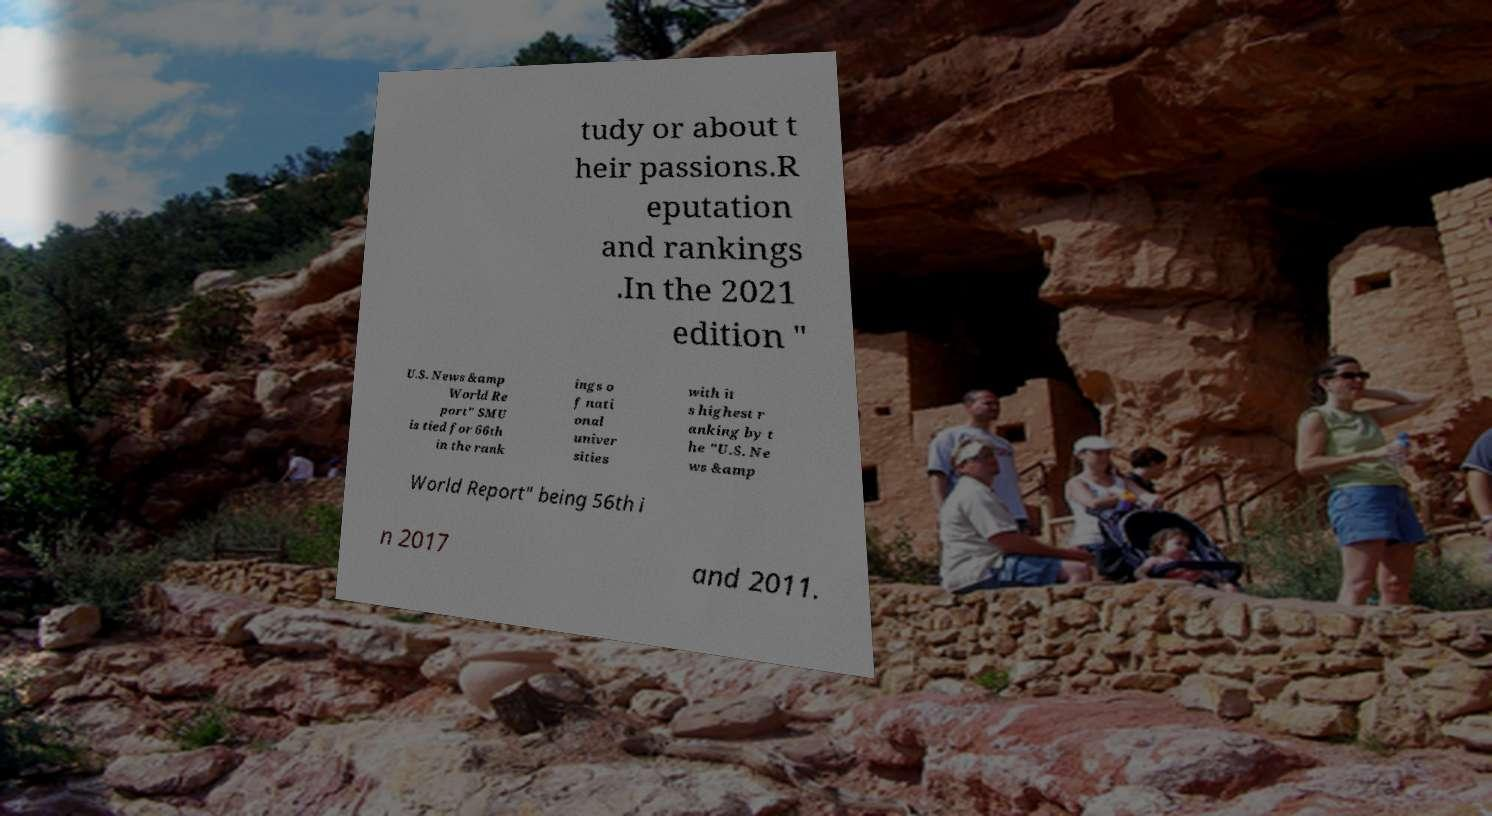For documentation purposes, I need the text within this image transcribed. Could you provide that? tudy or about t heir passions.R eputation and rankings .In the 2021 edition " U.S. News &amp World Re port" SMU is tied for 66th in the rank ings o f nati onal univer sities with it s highest r anking by t he "U.S. Ne ws &amp World Report" being 56th i n 2017 and 2011. 